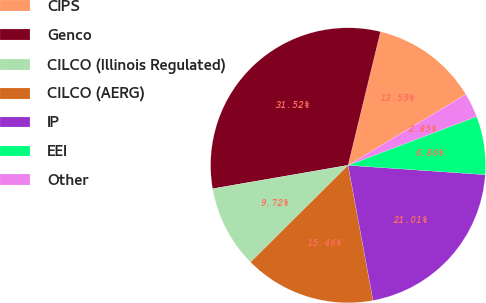Convert chart. <chart><loc_0><loc_0><loc_500><loc_500><pie_chart><fcel>CIPS<fcel>Genco<fcel>CILCO (Illinois Regulated)<fcel>CILCO (AERG)<fcel>IP<fcel>EEI<fcel>Other<nl><fcel>12.59%<fcel>31.52%<fcel>9.72%<fcel>15.46%<fcel>21.01%<fcel>6.86%<fcel>2.85%<nl></chart> 